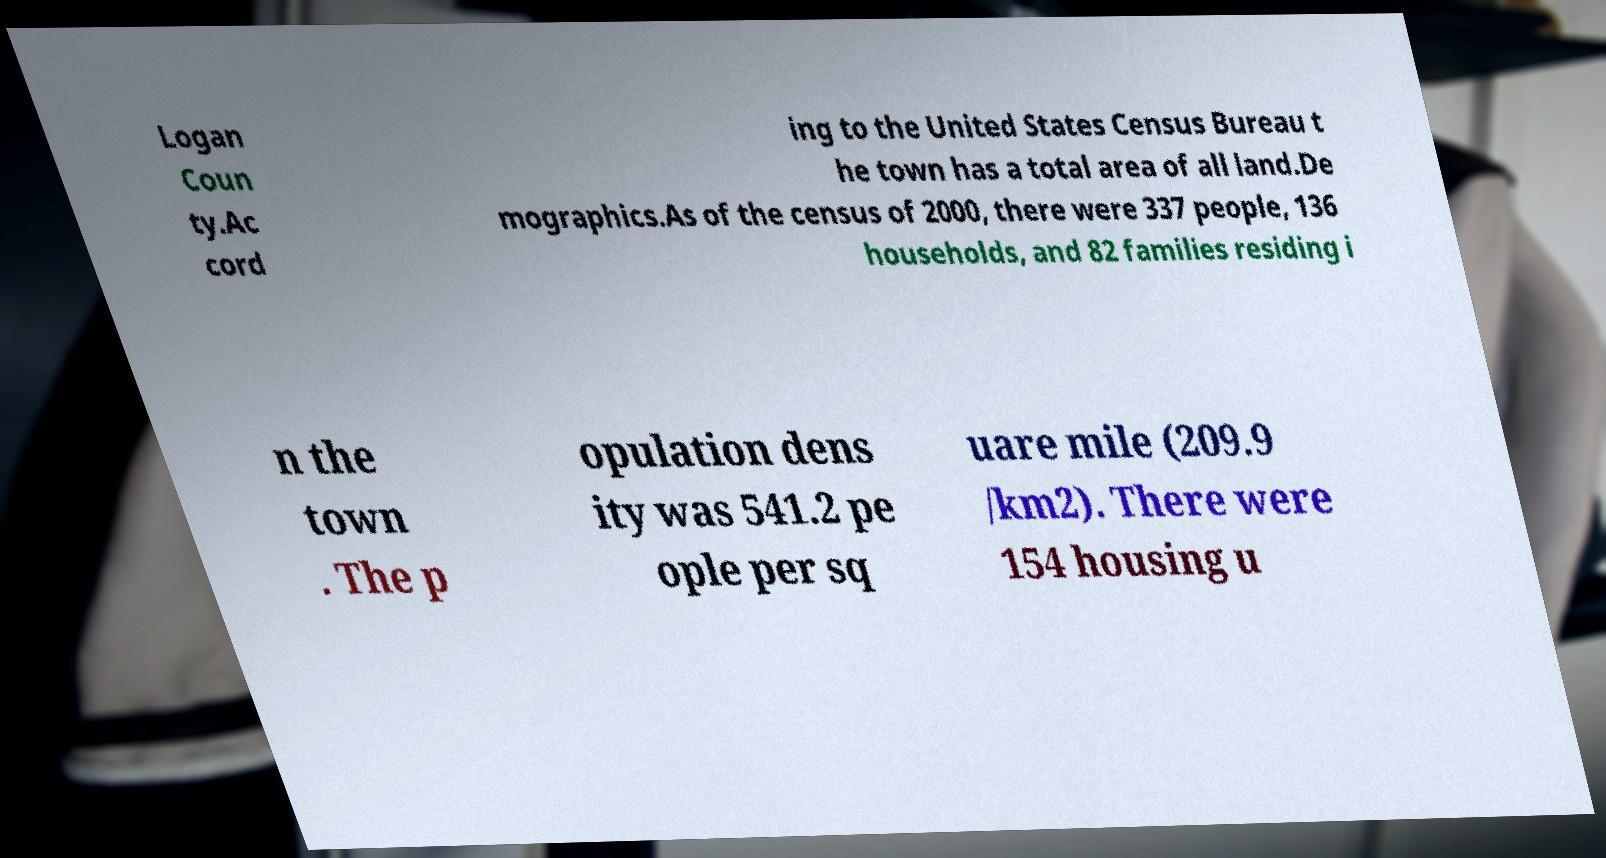There's text embedded in this image that I need extracted. Can you transcribe it verbatim? Logan Coun ty.Ac cord ing to the United States Census Bureau t he town has a total area of all land.De mographics.As of the census of 2000, there were 337 people, 136 households, and 82 families residing i n the town . The p opulation dens ity was 541.2 pe ople per sq uare mile (209.9 /km2). There were 154 housing u 